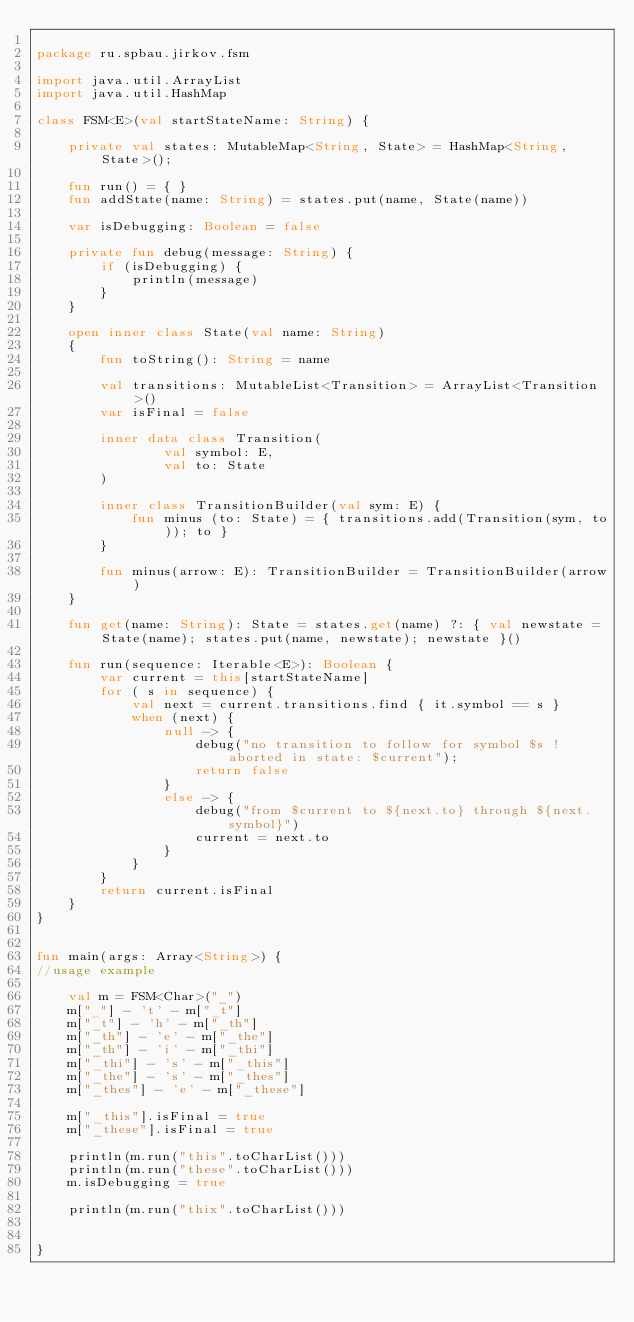<code> <loc_0><loc_0><loc_500><loc_500><_Kotlin_>
package ru.spbau.jirkov.fsm

import java.util.ArrayList
import java.util.HashMap

class FSM<E>(val startStateName: String) {

    private val states: MutableMap<String, State> = HashMap<String, State>();

    fun run() = { }
    fun addState(name: String) = states.put(name, State(name))

    var isDebugging: Boolean = false

    private fun debug(message: String) {
        if (isDebugging) {
            println(message)
        }
    }

    open inner class State(val name: String)
    {
        fun toString(): String = name

        val transitions: MutableList<Transition> = ArrayList<Transition>()
        var isFinal = false

        inner data class Transition(
                val symbol: E,
                val to: State
        )

        inner class TransitionBuilder(val sym: E) {
            fun minus (to: State) = { transitions.add(Transition(sym, to)); to }
        }

        fun minus(arrow: E): TransitionBuilder = TransitionBuilder(arrow)
    }

    fun get(name: String): State = states.get(name) ?: { val newstate = State(name); states.put(name, newstate); newstate }()

    fun run(sequence: Iterable<E>): Boolean {
        var current = this[startStateName]
        for ( s in sequence) {
            val next = current.transitions.find { it.symbol == s }
            when (next) {
                null -> {
                    debug("no transition to follow for symbol $s ! aborted in state: $current");
                    return false
                }
                else -> {
                    debug("from $current to ${next.to} through ${next.symbol}")
                    current = next.to
                }
            }
        }
        return current.isFinal
    }
}


fun main(args: Array<String>) {
//usage example

    val m = FSM<Char>("_")
    m["_"] - 't' - m["_t"]
    m["_t"] - 'h' - m["_th"]
    m["_th"] - 'e' - m["_the"]
    m["_th"] - 'i' - m["_thi"]
    m["_thi"] - 's' - m["_this"]
    m["_the"] - 's' - m["_thes"]
    m["_thes"] - 'e' - m["_these"]

    m["_this"].isFinal = true
    m["_these"].isFinal = true

    println(m.run("this".toCharList()))
    println(m.run("these".toCharList()))
    m.isDebugging = true

    println(m.run("thix".toCharList()))


}
</code> 